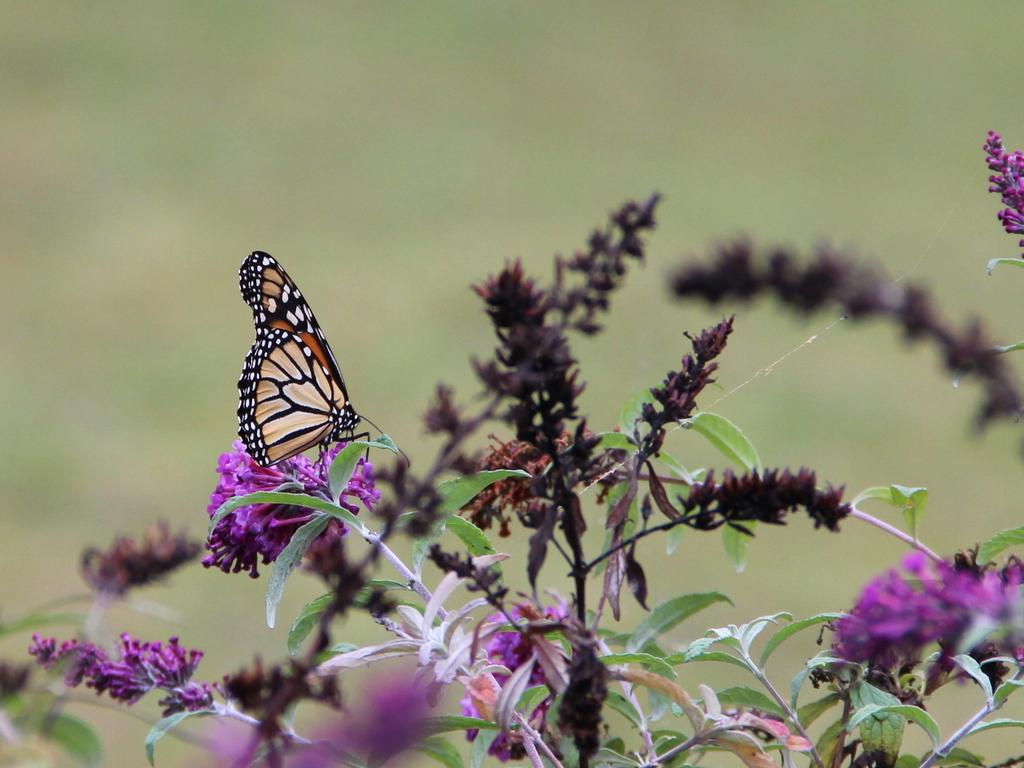What type of plants are present in the image? There are plants with flowers in the image. Can you describe any specific details about the plants? Yes, there is a butterfly on one of the plants in the image. Where is the nearest store to buy a turkey in the image? There is no store or turkey present in the image; it features plants with flowers and a butterfly. 